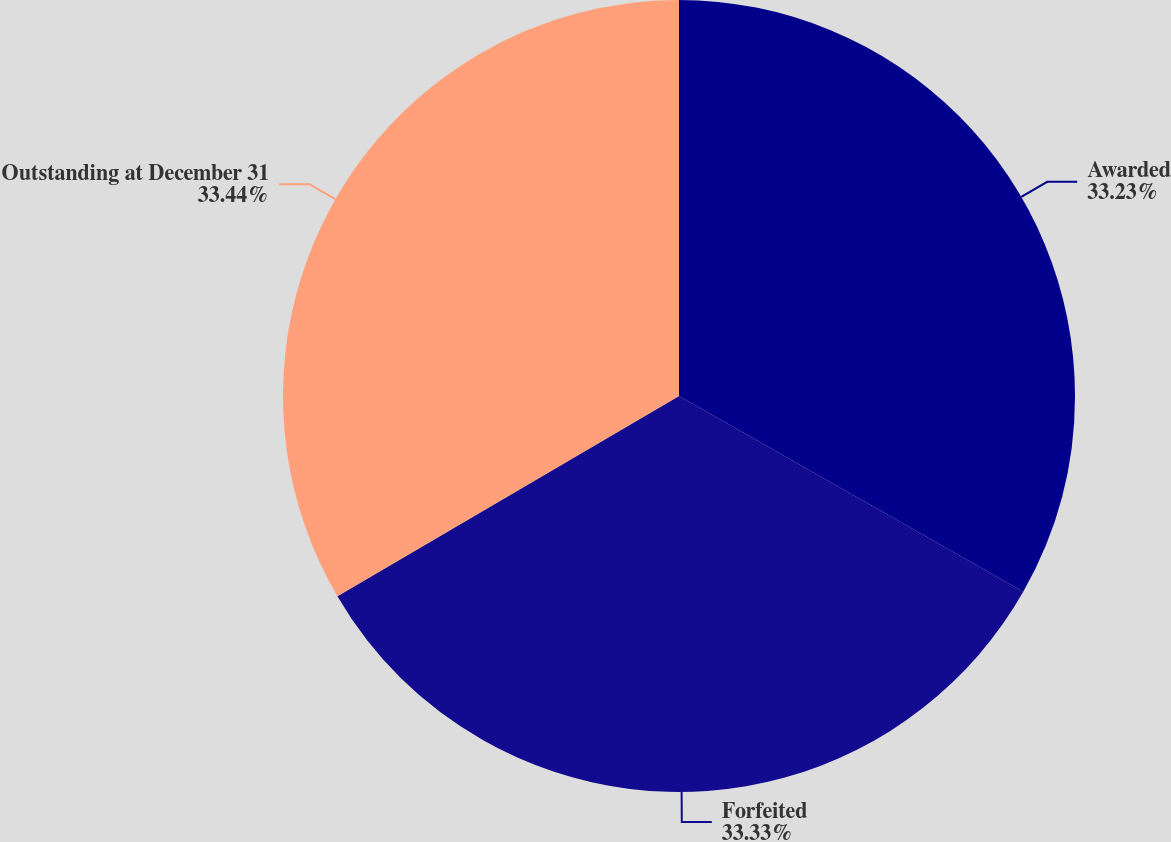Convert chart. <chart><loc_0><loc_0><loc_500><loc_500><pie_chart><fcel>Awarded<fcel>Forfeited<fcel>Outstanding at December 31<nl><fcel>33.23%<fcel>33.33%<fcel>33.44%<nl></chart> 